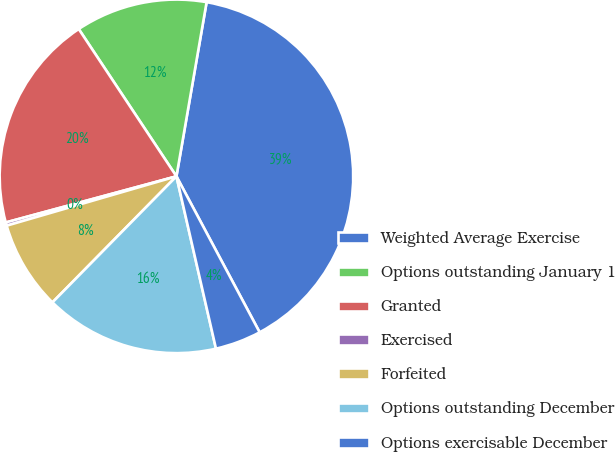Convert chart to OTSL. <chart><loc_0><loc_0><loc_500><loc_500><pie_chart><fcel>Weighted Average Exercise<fcel>Options outstanding January 1<fcel>Granted<fcel>Exercised<fcel>Forfeited<fcel>Options outstanding December<fcel>Options exercisable December<nl><fcel>39.47%<fcel>12.05%<fcel>19.88%<fcel>0.3%<fcel>8.13%<fcel>15.96%<fcel>4.21%<nl></chart> 